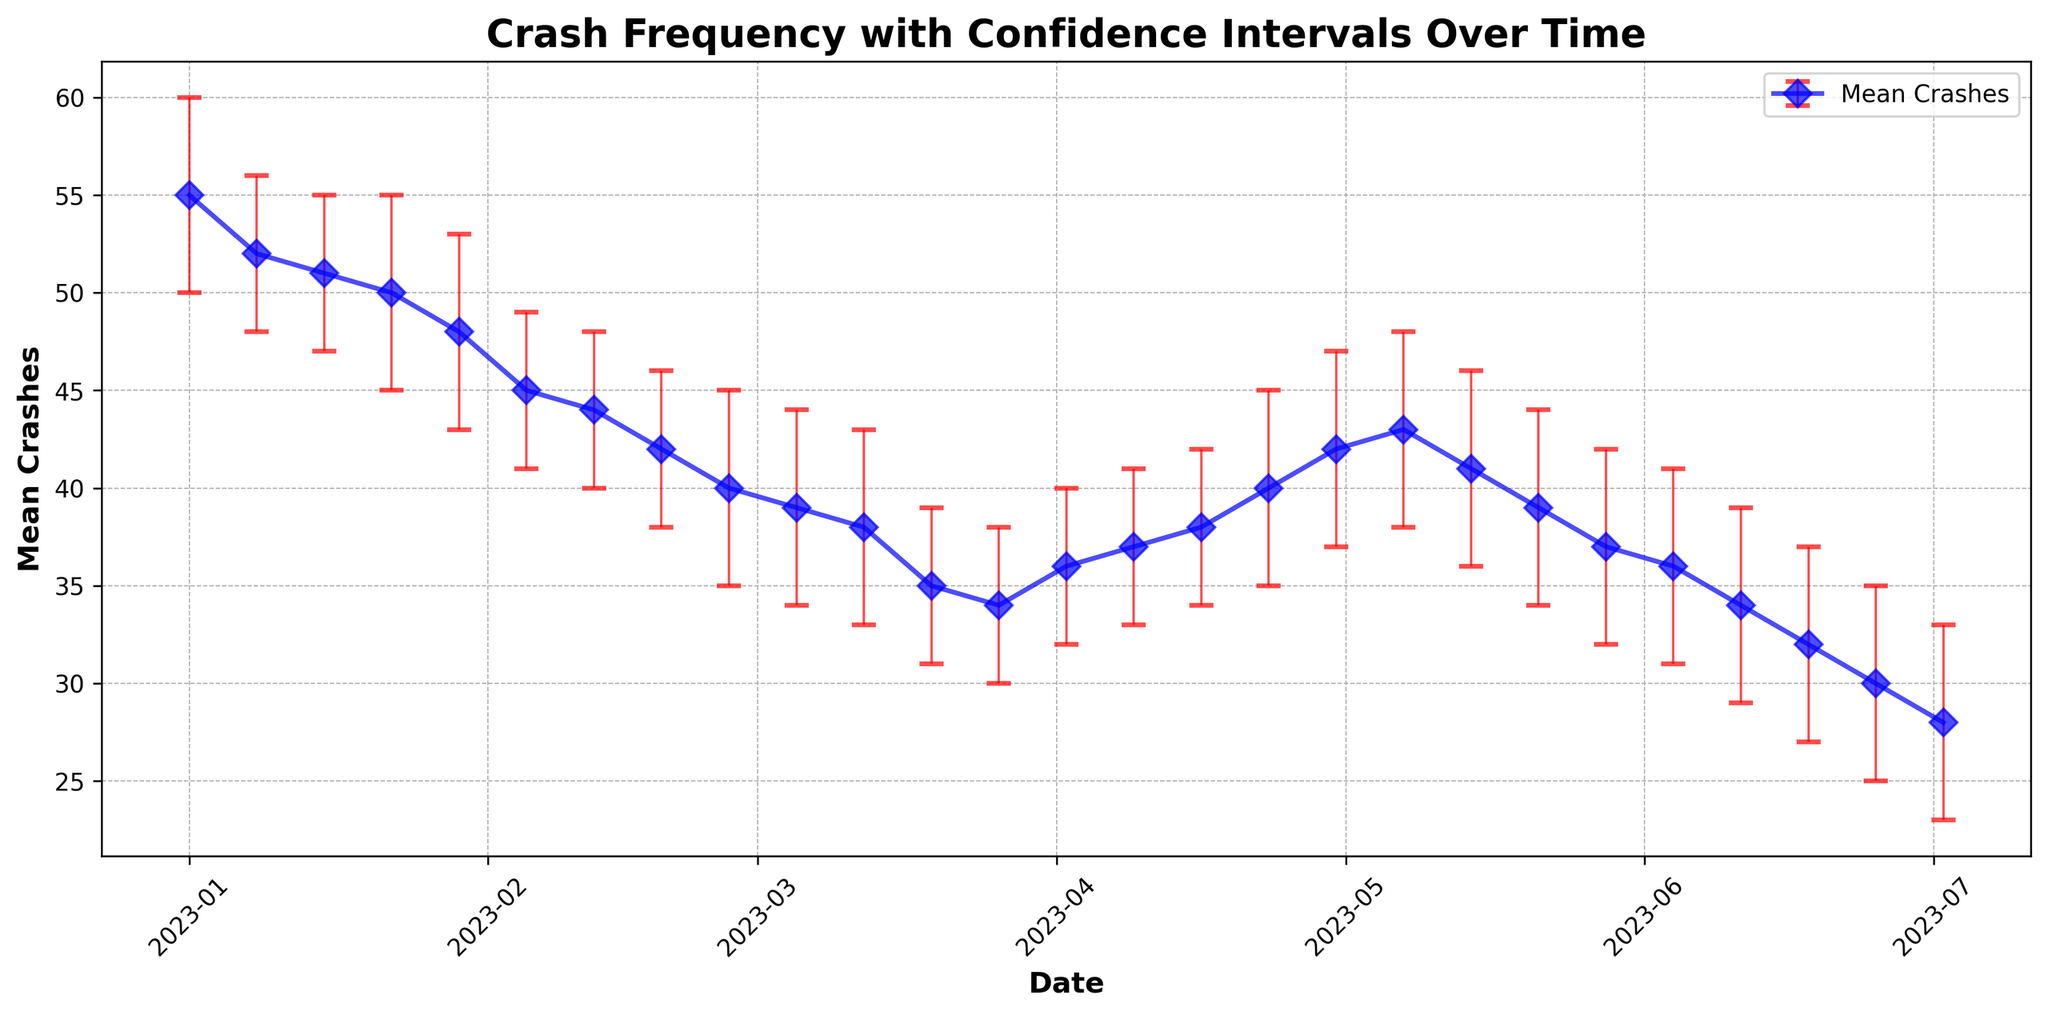What is the trend in the mean number of crashes before and after the major update? Examine the line representing the mean crashes from the start (January 2023) to the end (July 2023). It's clear that the mean number of crashes generally decreases over time, indicating an improvement after the major update.
Answer: Downward trend Between April and June, which month had the highest mean crashes? Investigate the peaks in the plotted line from April to June. The highest mean crashes appear to be in April.
Answer: April What is the confidence interval for the mean number of crashes on March 12, 2023? Look at the data point for March 12, 2023. The lower bound is 33, the mean is 38, and the upper bound is 43.
Answer: [33, 43] How does the error bar for April 30, 2023, compare with that for February 26, 2023? Assess the lengths of the error bars for both dates. The error bar on February 26 is longer than the one on April 30, indicating more variability in crashes in February.
Answer: Longer in February What was the mean crash reduction from January 1 to July 2, 2023? Subtract the mean crashes on July 2 (28) from those on January 1 (55). The mean crash reduction is 55 - 28 = 27.
Answer: 27 Which date had the smallest mean crashes and what was that value? Identify the lowest point in the mean crash line. The smallest value is on July 2, 2023, with a mean of 28 crashes.
Answer: July 2, 28 crashes What was the approximate total decrease in the upper bound of crash intervals from January 1 to July 2, 2023? Subtract the upper bound on July 2 (33) from the upper bound on January 1 (60). The total decrease is 60 - 33 = 27.
Answer: 27 Between which two consecutive weeks was the sharpest decrease in mean crashes observed? Compare the slopes between consecutive data points. The sharpest decrease is between January 22 and January 29.
Answer: January 22 to January 29 Considering only February 12 to March 12, did the mean number of crashes consistently decrease? Look at the mean crash values during this period: 44, 42, 40, 39, 38. Each week shows a decrease, indicating a consistent downward trend.
Answer: Yes Is there a noticeable change in the variability (range) of crashes before and after the update period in mid-March? Observe the lengths of error bars before and after mid-March. There is a general reduction in the length of error bars post-update, indicating less variability.
Answer: Less variability after the update 